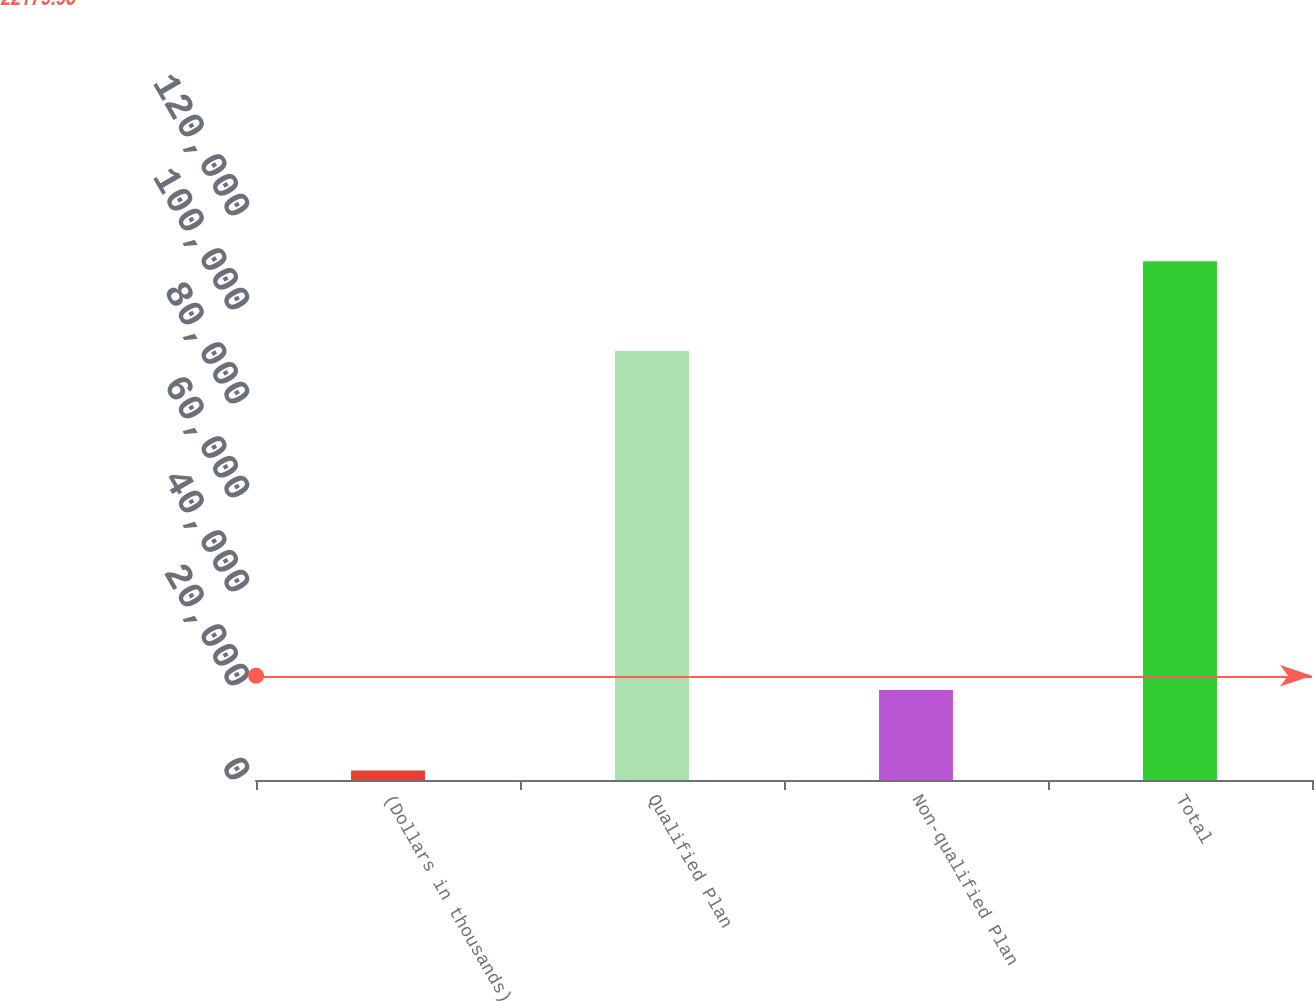Convert chart to OTSL. <chart><loc_0><loc_0><loc_500><loc_500><bar_chart><fcel>(Dollars in thousands)<fcel>Qualified Plan<fcel>Non-qualified Plan<fcel>Total<nl><fcel>2010<fcel>91254<fcel>19141<fcel>110395<nl></chart> 